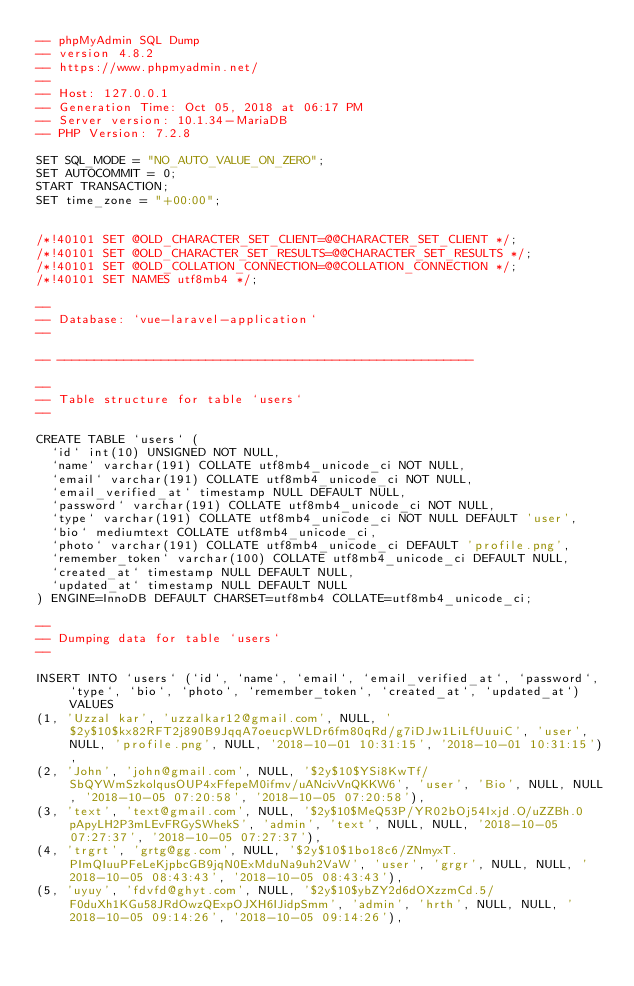<code> <loc_0><loc_0><loc_500><loc_500><_SQL_>-- phpMyAdmin SQL Dump
-- version 4.8.2
-- https://www.phpmyadmin.net/
--
-- Host: 127.0.0.1
-- Generation Time: Oct 05, 2018 at 06:17 PM
-- Server version: 10.1.34-MariaDB
-- PHP Version: 7.2.8

SET SQL_MODE = "NO_AUTO_VALUE_ON_ZERO";
SET AUTOCOMMIT = 0;
START TRANSACTION;
SET time_zone = "+00:00";


/*!40101 SET @OLD_CHARACTER_SET_CLIENT=@@CHARACTER_SET_CLIENT */;
/*!40101 SET @OLD_CHARACTER_SET_RESULTS=@@CHARACTER_SET_RESULTS */;
/*!40101 SET @OLD_COLLATION_CONNECTION=@@COLLATION_CONNECTION */;
/*!40101 SET NAMES utf8mb4 */;

--
-- Database: `vue-laravel-application`
--

-- --------------------------------------------------------

--
-- Table structure for table `users`
--

CREATE TABLE `users` (
  `id` int(10) UNSIGNED NOT NULL,
  `name` varchar(191) COLLATE utf8mb4_unicode_ci NOT NULL,
  `email` varchar(191) COLLATE utf8mb4_unicode_ci NOT NULL,
  `email_verified_at` timestamp NULL DEFAULT NULL,
  `password` varchar(191) COLLATE utf8mb4_unicode_ci NOT NULL,
  `type` varchar(191) COLLATE utf8mb4_unicode_ci NOT NULL DEFAULT 'user',
  `bio` mediumtext COLLATE utf8mb4_unicode_ci,
  `photo` varchar(191) COLLATE utf8mb4_unicode_ci DEFAULT 'profile.png',
  `remember_token` varchar(100) COLLATE utf8mb4_unicode_ci DEFAULT NULL,
  `created_at` timestamp NULL DEFAULT NULL,
  `updated_at` timestamp NULL DEFAULT NULL
) ENGINE=InnoDB DEFAULT CHARSET=utf8mb4 COLLATE=utf8mb4_unicode_ci;

--
-- Dumping data for table `users`
--

INSERT INTO `users` (`id`, `name`, `email`, `email_verified_at`, `password`, `type`, `bio`, `photo`, `remember_token`, `created_at`, `updated_at`) VALUES
(1, 'Uzzal kar', 'uzzalkar12@gmail.com', NULL, '$2y$10$kx82RFT2j890B9JqqA7oeucpWLDr6fm80qRd/g7iDJw1LiLfUuuiC', 'user', NULL, 'profile.png', NULL, '2018-10-01 10:31:15', '2018-10-01 10:31:15'),
(2, 'John', 'john@gmail.com', NULL, '$2y$10$YSi8KwTf/SbQYWmSzkolqusOUP4xFfepeM0ifmv/uANcivVnQKKW6', 'user', 'Bio', NULL, NULL, '2018-10-05 07:20:58', '2018-10-05 07:20:58'),
(3, 'text', 'text@gmail.com', NULL, '$2y$10$MeQ53P/YR02bOj54Ixjd.O/uZZBh.0pApyLH2P3mLEvFRGySWhekS', 'admin', 'text', NULL, NULL, '2018-10-05 07:27:37', '2018-10-05 07:27:37'),
(4, 'trgrt', 'grtg@gg.com', NULL, '$2y$10$1bo18c6/ZNmyxT.PImQIuuPFeLeKjpbcGB9jqN0ExMduNa9uh2VaW', 'user', 'grgr', NULL, NULL, '2018-10-05 08:43:43', '2018-10-05 08:43:43'),
(5, 'uyuy', 'fdvfd@ghyt.com', NULL, '$2y$10$ybZY2d6dOXzzmCd.5/F0duXh1KGu58JRdOwzQExpOJXH6IJidpSmm', 'admin', 'hrth', NULL, NULL, '2018-10-05 09:14:26', '2018-10-05 09:14:26'),</code> 